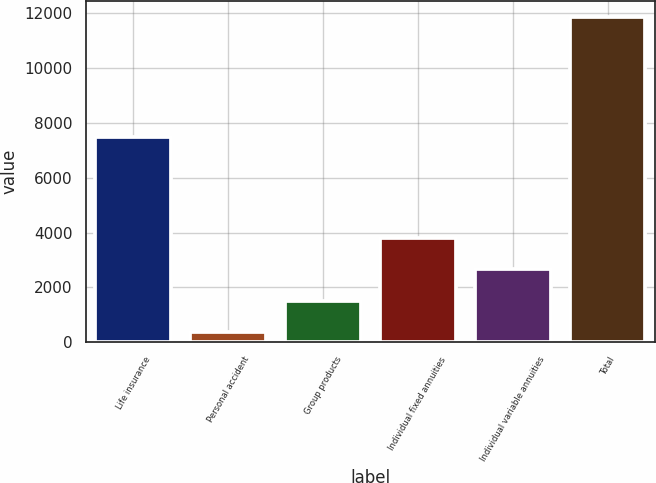Convert chart to OTSL. <chart><loc_0><loc_0><loc_500><loc_500><bar_chart><fcel>Life insurance<fcel>Personal accident<fcel>Group products<fcel>Individual fixed annuities<fcel>Individual variable annuities<fcel>Total<nl><fcel>7473<fcel>354<fcel>1503.5<fcel>3802.5<fcel>2653<fcel>11849<nl></chart> 